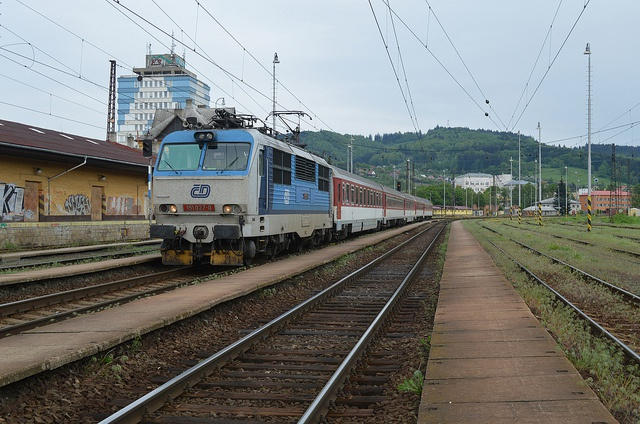Describe the objects in this image and their specific colors. I can see a train in lavender, black, darkgray, and gray tones in this image. 